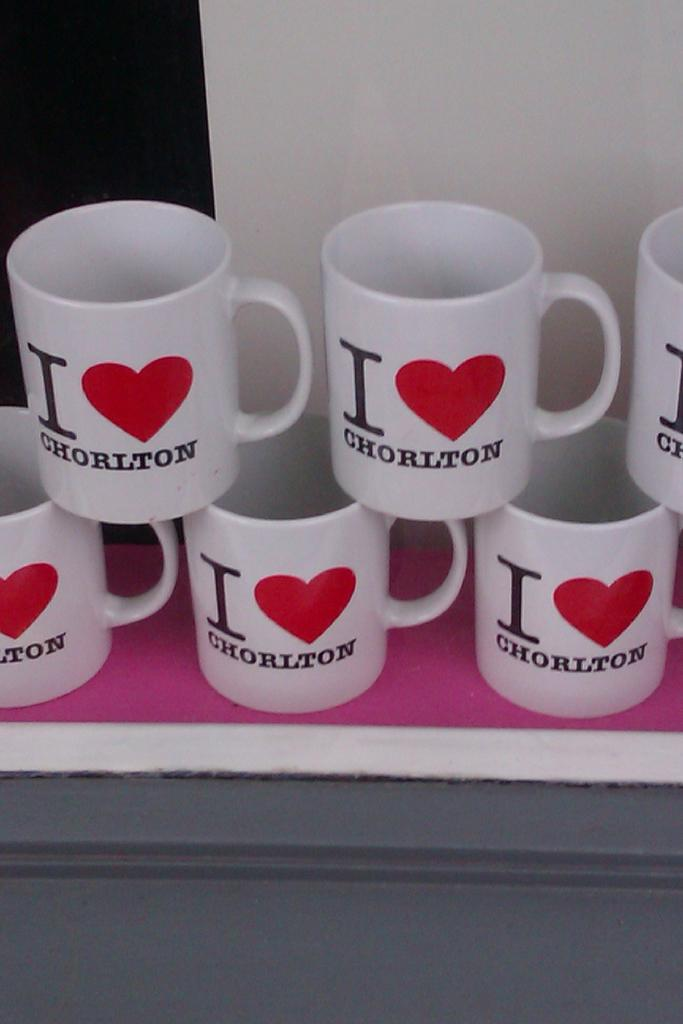What objects are present in the image? There are coffee cups in the image. How are the coffee cups arranged? The coffee cups are arranged in a row. What can be seen in the background of the image? There is a wall in the background of the image. What type of ring is visible on the wall in the image? There is no ring present on the wall in the image. 